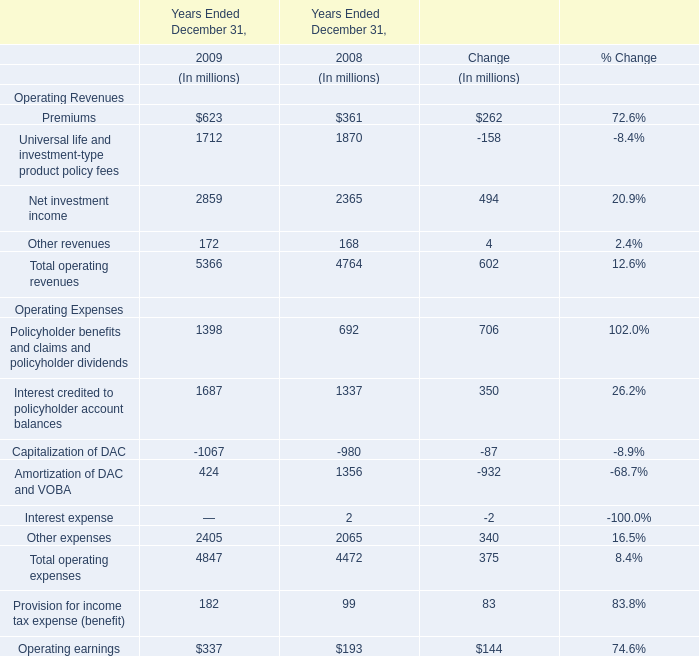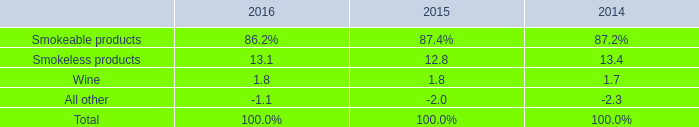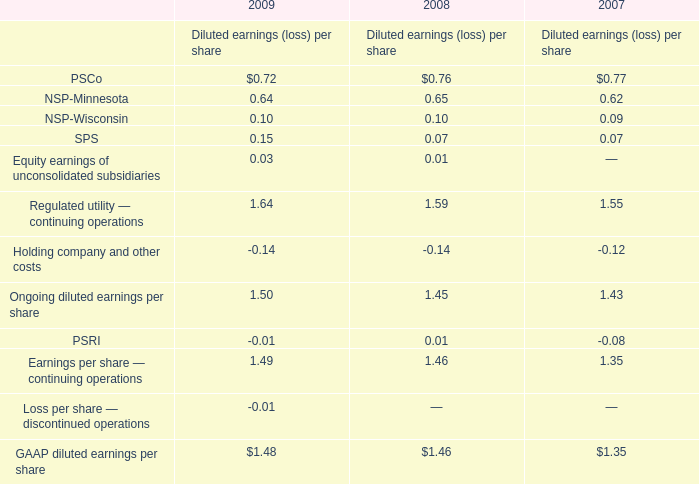what is the total units of shipment volume for smokeless products in 2015 , in millions? 
Computations: (853.5 / (100 + 4.9%))
Answer: 8.53082. 